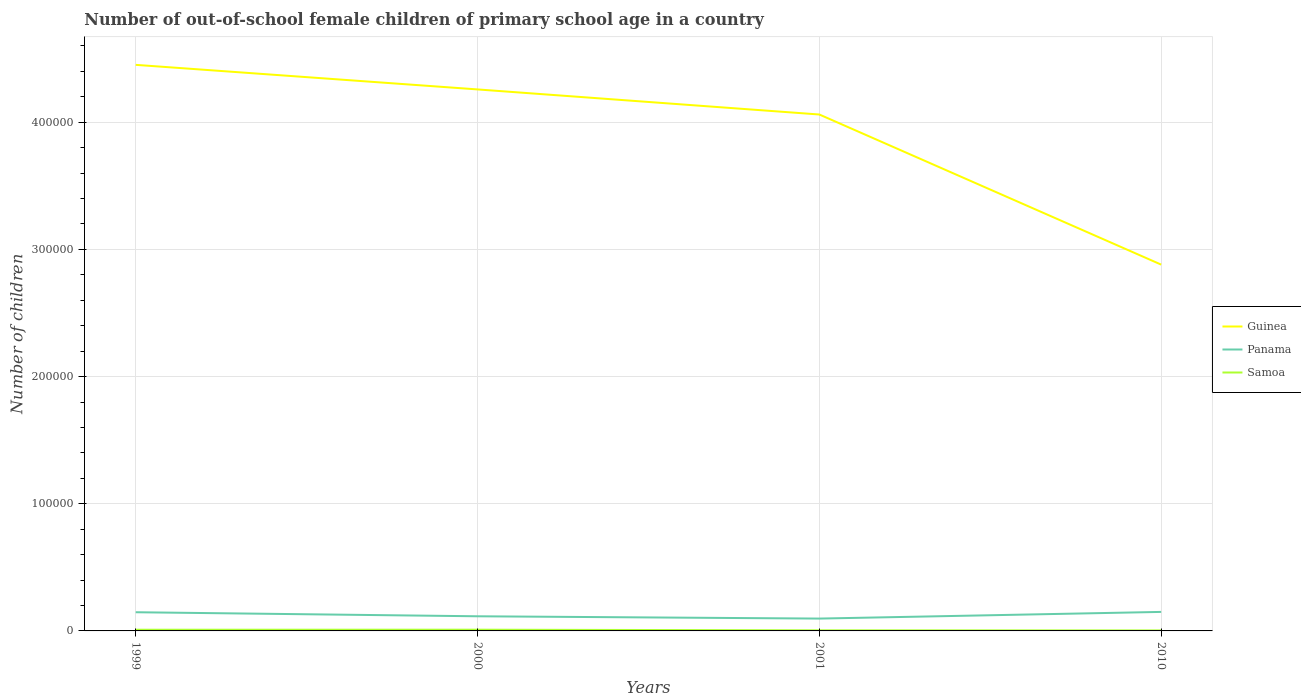Across all years, what is the maximum number of out-of-school female children in Guinea?
Provide a short and direct response. 2.88e+05. In which year was the number of out-of-school female children in Guinea maximum?
Provide a short and direct response. 2010. What is the total number of out-of-school female children in Panama in the graph?
Make the answer very short. -3443. What is the difference between the highest and the second highest number of out-of-school female children in Guinea?
Offer a terse response. 1.57e+05. What is the difference between two consecutive major ticks on the Y-axis?
Ensure brevity in your answer.  1.00e+05. Are the values on the major ticks of Y-axis written in scientific E-notation?
Offer a very short reply. No. Does the graph contain any zero values?
Make the answer very short. No. Does the graph contain grids?
Provide a succinct answer. Yes. How many legend labels are there?
Your answer should be compact. 3. How are the legend labels stacked?
Give a very brief answer. Vertical. What is the title of the graph?
Your answer should be very brief. Number of out-of-school female children of primary school age in a country. Does "Afghanistan" appear as one of the legend labels in the graph?
Keep it short and to the point. No. What is the label or title of the Y-axis?
Offer a very short reply. Number of children. What is the Number of children in Guinea in 1999?
Offer a terse response. 4.45e+05. What is the Number of children in Panama in 1999?
Keep it short and to the point. 1.47e+04. What is the Number of children in Samoa in 1999?
Ensure brevity in your answer.  929. What is the Number of children in Guinea in 2000?
Your answer should be very brief. 4.26e+05. What is the Number of children in Panama in 2000?
Offer a terse response. 1.15e+04. What is the Number of children in Samoa in 2000?
Keep it short and to the point. 967. What is the Number of children of Guinea in 2001?
Provide a succinct answer. 4.06e+05. What is the Number of children in Panama in 2001?
Offer a terse response. 9706. What is the Number of children in Samoa in 2001?
Provide a short and direct response. 470. What is the Number of children in Guinea in 2010?
Offer a very short reply. 2.88e+05. What is the Number of children in Panama in 2010?
Give a very brief answer. 1.50e+04. What is the Number of children in Samoa in 2010?
Offer a terse response. 391. Across all years, what is the maximum Number of children of Guinea?
Your answer should be very brief. 4.45e+05. Across all years, what is the maximum Number of children in Panama?
Offer a very short reply. 1.50e+04. Across all years, what is the maximum Number of children in Samoa?
Your answer should be very brief. 967. Across all years, what is the minimum Number of children of Guinea?
Keep it short and to the point. 2.88e+05. Across all years, what is the minimum Number of children in Panama?
Make the answer very short. 9706. Across all years, what is the minimum Number of children in Samoa?
Make the answer very short. 391. What is the total Number of children of Guinea in the graph?
Your response must be concise. 1.57e+06. What is the total Number of children in Panama in the graph?
Provide a short and direct response. 5.09e+04. What is the total Number of children of Samoa in the graph?
Your answer should be very brief. 2757. What is the difference between the Number of children in Guinea in 1999 and that in 2000?
Offer a terse response. 1.93e+04. What is the difference between the Number of children in Panama in 1999 and that in 2000?
Make the answer very short. 3180. What is the difference between the Number of children of Samoa in 1999 and that in 2000?
Your answer should be compact. -38. What is the difference between the Number of children of Guinea in 1999 and that in 2001?
Ensure brevity in your answer.  3.90e+04. What is the difference between the Number of children in Panama in 1999 and that in 2001?
Make the answer very short. 4983. What is the difference between the Number of children in Samoa in 1999 and that in 2001?
Offer a very short reply. 459. What is the difference between the Number of children in Guinea in 1999 and that in 2010?
Ensure brevity in your answer.  1.57e+05. What is the difference between the Number of children in Panama in 1999 and that in 2010?
Give a very brief answer. -263. What is the difference between the Number of children in Samoa in 1999 and that in 2010?
Provide a short and direct response. 538. What is the difference between the Number of children of Guinea in 2000 and that in 2001?
Keep it short and to the point. 1.97e+04. What is the difference between the Number of children of Panama in 2000 and that in 2001?
Provide a short and direct response. 1803. What is the difference between the Number of children in Samoa in 2000 and that in 2001?
Provide a succinct answer. 497. What is the difference between the Number of children of Guinea in 2000 and that in 2010?
Give a very brief answer. 1.38e+05. What is the difference between the Number of children of Panama in 2000 and that in 2010?
Give a very brief answer. -3443. What is the difference between the Number of children of Samoa in 2000 and that in 2010?
Your answer should be compact. 576. What is the difference between the Number of children of Guinea in 2001 and that in 2010?
Your response must be concise. 1.18e+05. What is the difference between the Number of children of Panama in 2001 and that in 2010?
Your answer should be very brief. -5246. What is the difference between the Number of children in Samoa in 2001 and that in 2010?
Your response must be concise. 79. What is the difference between the Number of children of Guinea in 1999 and the Number of children of Panama in 2000?
Your answer should be compact. 4.34e+05. What is the difference between the Number of children in Guinea in 1999 and the Number of children in Samoa in 2000?
Give a very brief answer. 4.44e+05. What is the difference between the Number of children of Panama in 1999 and the Number of children of Samoa in 2000?
Offer a terse response. 1.37e+04. What is the difference between the Number of children in Guinea in 1999 and the Number of children in Panama in 2001?
Offer a terse response. 4.35e+05. What is the difference between the Number of children in Guinea in 1999 and the Number of children in Samoa in 2001?
Your response must be concise. 4.45e+05. What is the difference between the Number of children of Panama in 1999 and the Number of children of Samoa in 2001?
Your answer should be very brief. 1.42e+04. What is the difference between the Number of children in Guinea in 1999 and the Number of children in Panama in 2010?
Your response must be concise. 4.30e+05. What is the difference between the Number of children of Guinea in 1999 and the Number of children of Samoa in 2010?
Make the answer very short. 4.45e+05. What is the difference between the Number of children of Panama in 1999 and the Number of children of Samoa in 2010?
Provide a succinct answer. 1.43e+04. What is the difference between the Number of children of Guinea in 2000 and the Number of children of Panama in 2001?
Offer a terse response. 4.16e+05. What is the difference between the Number of children of Guinea in 2000 and the Number of children of Samoa in 2001?
Your response must be concise. 4.25e+05. What is the difference between the Number of children in Panama in 2000 and the Number of children in Samoa in 2001?
Offer a terse response. 1.10e+04. What is the difference between the Number of children in Guinea in 2000 and the Number of children in Panama in 2010?
Offer a terse response. 4.11e+05. What is the difference between the Number of children in Guinea in 2000 and the Number of children in Samoa in 2010?
Give a very brief answer. 4.25e+05. What is the difference between the Number of children of Panama in 2000 and the Number of children of Samoa in 2010?
Give a very brief answer. 1.11e+04. What is the difference between the Number of children of Guinea in 2001 and the Number of children of Panama in 2010?
Your response must be concise. 3.91e+05. What is the difference between the Number of children in Guinea in 2001 and the Number of children in Samoa in 2010?
Provide a succinct answer. 4.06e+05. What is the difference between the Number of children of Panama in 2001 and the Number of children of Samoa in 2010?
Make the answer very short. 9315. What is the average Number of children in Guinea per year?
Offer a terse response. 3.91e+05. What is the average Number of children of Panama per year?
Offer a very short reply. 1.27e+04. What is the average Number of children of Samoa per year?
Provide a succinct answer. 689.25. In the year 1999, what is the difference between the Number of children in Guinea and Number of children in Panama?
Ensure brevity in your answer.  4.30e+05. In the year 1999, what is the difference between the Number of children in Guinea and Number of children in Samoa?
Provide a succinct answer. 4.44e+05. In the year 1999, what is the difference between the Number of children of Panama and Number of children of Samoa?
Ensure brevity in your answer.  1.38e+04. In the year 2000, what is the difference between the Number of children in Guinea and Number of children in Panama?
Make the answer very short. 4.14e+05. In the year 2000, what is the difference between the Number of children in Guinea and Number of children in Samoa?
Ensure brevity in your answer.  4.25e+05. In the year 2000, what is the difference between the Number of children of Panama and Number of children of Samoa?
Make the answer very short. 1.05e+04. In the year 2001, what is the difference between the Number of children in Guinea and Number of children in Panama?
Your response must be concise. 3.96e+05. In the year 2001, what is the difference between the Number of children in Guinea and Number of children in Samoa?
Provide a short and direct response. 4.06e+05. In the year 2001, what is the difference between the Number of children in Panama and Number of children in Samoa?
Offer a very short reply. 9236. In the year 2010, what is the difference between the Number of children of Guinea and Number of children of Panama?
Provide a succinct answer. 2.73e+05. In the year 2010, what is the difference between the Number of children in Guinea and Number of children in Samoa?
Make the answer very short. 2.88e+05. In the year 2010, what is the difference between the Number of children in Panama and Number of children in Samoa?
Your answer should be very brief. 1.46e+04. What is the ratio of the Number of children of Guinea in 1999 to that in 2000?
Ensure brevity in your answer.  1.05. What is the ratio of the Number of children in Panama in 1999 to that in 2000?
Your answer should be compact. 1.28. What is the ratio of the Number of children of Samoa in 1999 to that in 2000?
Make the answer very short. 0.96. What is the ratio of the Number of children in Guinea in 1999 to that in 2001?
Keep it short and to the point. 1.1. What is the ratio of the Number of children of Panama in 1999 to that in 2001?
Give a very brief answer. 1.51. What is the ratio of the Number of children of Samoa in 1999 to that in 2001?
Make the answer very short. 1.98. What is the ratio of the Number of children of Guinea in 1999 to that in 2010?
Offer a very short reply. 1.55. What is the ratio of the Number of children of Panama in 1999 to that in 2010?
Your answer should be very brief. 0.98. What is the ratio of the Number of children of Samoa in 1999 to that in 2010?
Provide a succinct answer. 2.38. What is the ratio of the Number of children in Guinea in 2000 to that in 2001?
Keep it short and to the point. 1.05. What is the ratio of the Number of children of Panama in 2000 to that in 2001?
Provide a short and direct response. 1.19. What is the ratio of the Number of children in Samoa in 2000 to that in 2001?
Provide a short and direct response. 2.06. What is the ratio of the Number of children in Guinea in 2000 to that in 2010?
Your answer should be very brief. 1.48. What is the ratio of the Number of children of Panama in 2000 to that in 2010?
Your answer should be compact. 0.77. What is the ratio of the Number of children of Samoa in 2000 to that in 2010?
Your answer should be compact. 2.47. What is the ratio of the Number of children of Guinea in 2001 to that in 2010?
Provide a succinct answer. 1.41. What is the ratio of the Number of children of Panama in 2001 to that in 2010?
Provide a short and direct response. 0.65. What is the ratio of the Number of children in Samoa in 2001 to that in 2010?
Offer a very short reply. 1.2. What is the difference between the highest and the second highest Number of children in Guinea?
Ensure brevity in your answer.  1.93e+04. What is the difference between the highest and the second highest Number of children in Panama?
Provide a succinct answer. 263. What is the difference between the highest and the second highest Number of children in Samoa?
Ensure brevity in your answer.  38. What is the difference between the highest and the lowest Number of children of Guinea?
Your answer should be compact. 1.57e+05. What is the difference between the highest and the lowest Number of children in Panama?
Provide a succinct answer. 5246. What is the difference between the highest and the lowest Number of children of Samoa?
Provide a succinct answer. 576. 